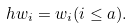<formula> <loc_0><loc_0><loc_500><loc_500>h w _ { i } = w _ { i } ( i \leq a ) .</formula> 